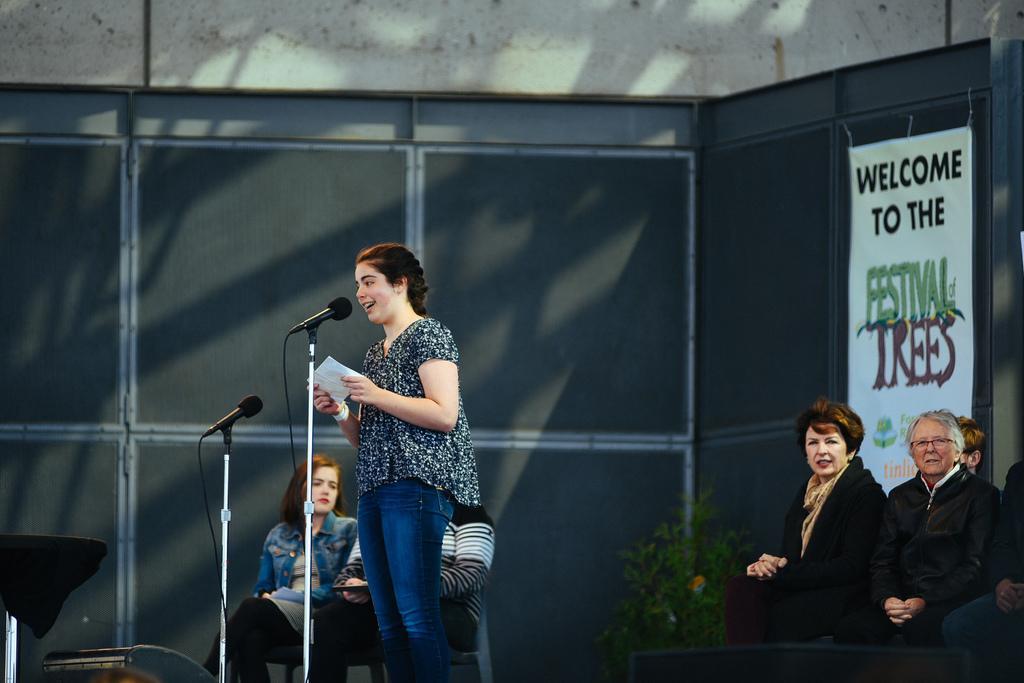Describe this image in one or two sentences. In this image in the center there is one woman standing and she is holding papers it seems that she is singing. In front of her there is mike, and in the background there are group of people sitting on chairs and there is a table and some boards and wall. 